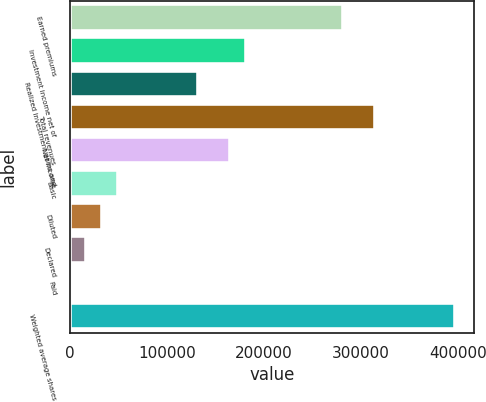Convert chart. <chart><loc_0><loc_0><loc_500><loc_500><bar_chart><fcel>Earned premiums<fcel>Investment income net of<fcel>Realized investment gains and<fcel>Total revenues<fcel>Net income<fcel>Basic<fcel>Diluted<fcel>Declared<fcel>Paid<fcel>Weighted average shares<nl><fcel>281179<fcel>181940<fcel>132320<fcel>314259<fcel>165400<fcel>49621.2<fcel>33081.3<fcel>16541.5<fcel>1.64<fcel>396958<nl></chart> 